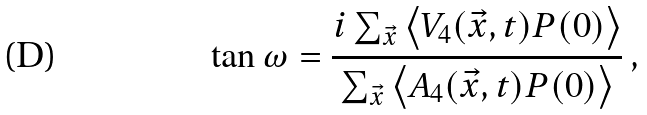<formula> <loc_0><loc_0><loc_500><loc_500>\tan \omega = \frac { i \sum _ { \vec { x } } \left < V _ { 4 } ( \vec { x } , t ) P ( 0 ) \right > } { \sum _ { \vec { x } } \left < A _ { 4 } ( \vec { x } , t ) P ( 0 ) \right > } \, ,</formula> 